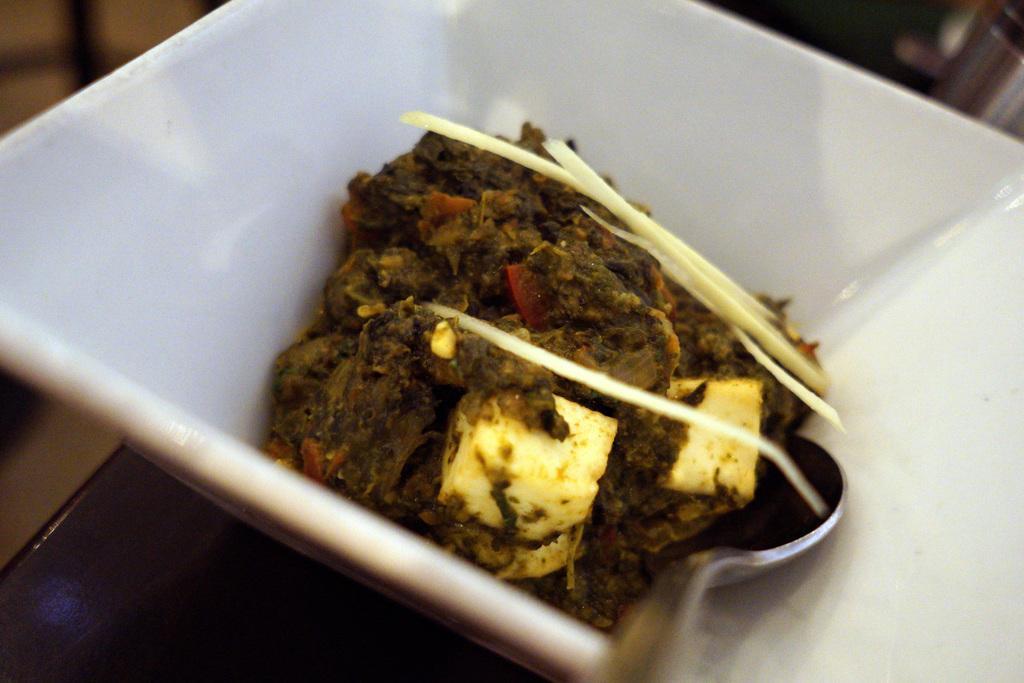How would you summarize this image in a sentence or two? In the image there is some cooked food item served in a cup and there is also a spoon beside the food. 